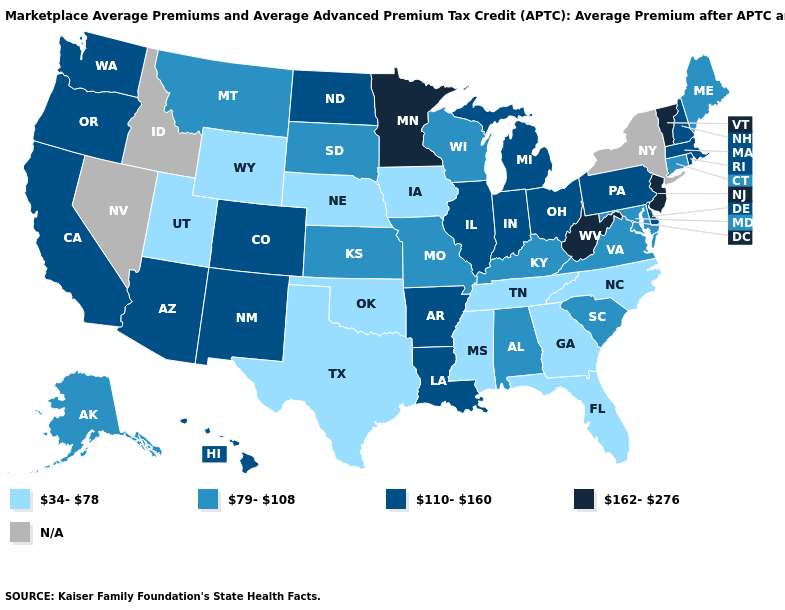Does the map have missing data?
Write a very short answer. Yes. What is the highest value in the USA?
Short answer required. 162-276. Name the states that have a value in the range 79-108?
Short answer required. Alabama, Alaska, Connecticut, Kansas, Kentucky, Maine, Maryland, Missouri, Montana, South Carolina, South Dakota, Virginia, Wisconsin. Does Indiana have the lowest value in the MidWest?
Short answer required. No. Name the states that have a value in the range N/A?
Give a very brief answer. Idaho, Nevada, New York. Name the states that have a value in the range 34-78?
Give a very brief answer. Florida, Georgia, Iowa, Mississippi, Nebraska, North Carolina, Oklahoma, Tennessee, Texas, Utah, Wyoming. Does Wyoming have the lowest value in the West?
Concise answer only. Yes. Among the states that border South Dakota , which have the lowest value?
Keep it brief. Iowa, Nebraska, Wyoming. Among the states that border Kansas , does Colorado have the highest value?
Answer briefly. Yes. Does the map have missing data?
Concise answer only. Yes. Which states have the lowest value in the West?
Keep it brief. Utah, Wyoming. Name the states that have a value in the range 110-160?
Short answer required. Arizona, Arkansas, California, Colorado, Delaware, Hawaii, Illinois, Indiana, Louisiana, Massachusetts, Michigan, New Hampshire, New Mexico, North Dakota, Ohio, Oregon, Pennsylvania, Rhode Island, Washington. Does New Hampshire have the highest value in the Northeast?
Concise answer only. No. What is the value of Idaho?
Give a very brief answer. N/A. 